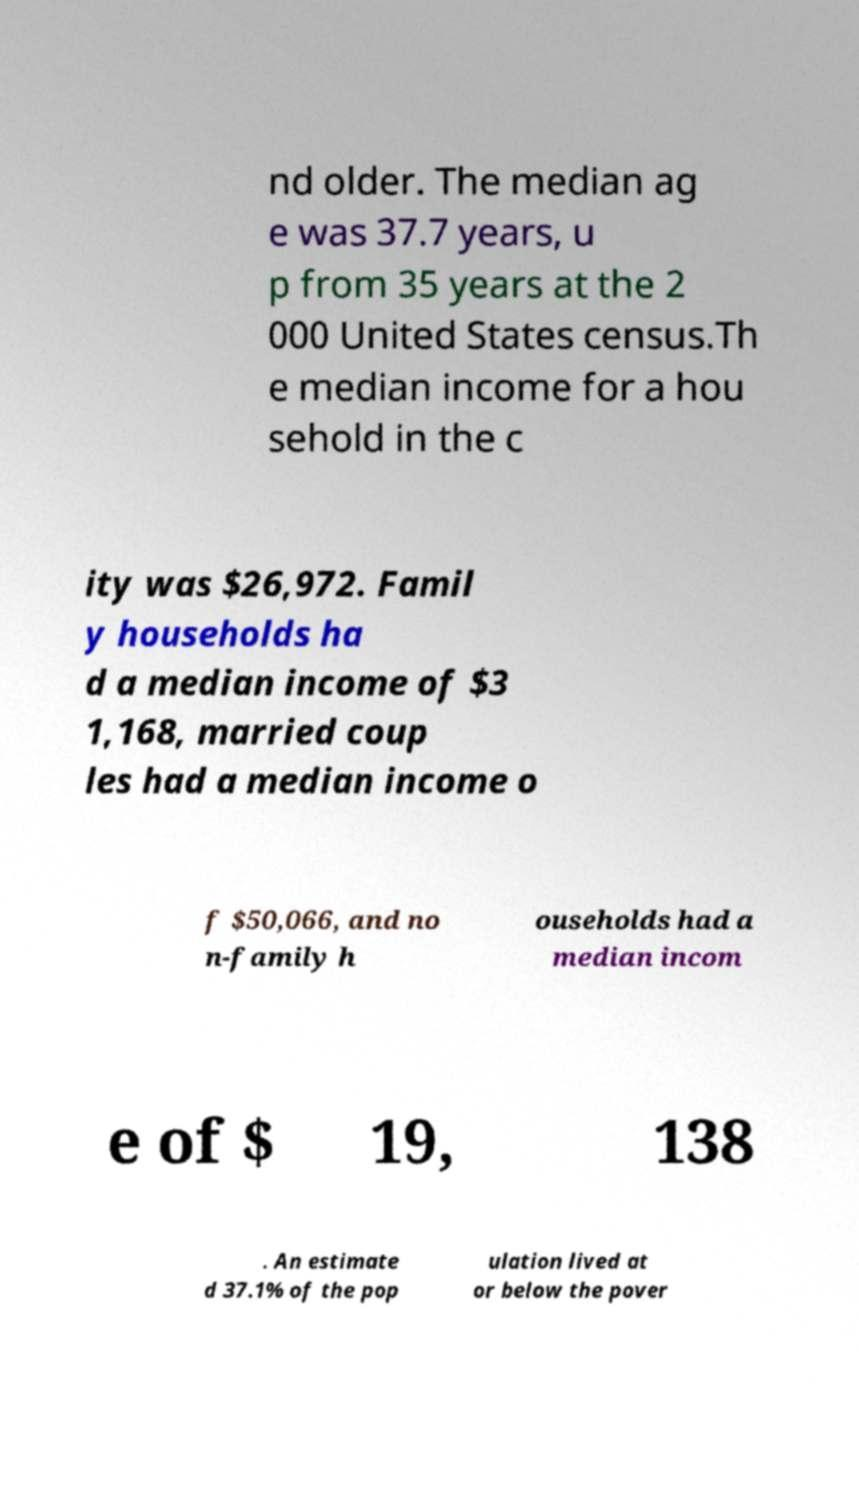For documentation purposes, I need the text within this image transcribed. Could you provide that? nd older. The median ag e was 37.7 years, u p from 35 years at the 2 000 United States census.Th e median income for a hou sehold in the c ity was $26,972. Famil y households ha d a median income of $3 1,168, married coup les had a median income o f $50,066, and no n-family h ouseholds had a median incom e of $ 19, 138 . An estimate d 37.1% of the pop ulation lived at or below the pover 